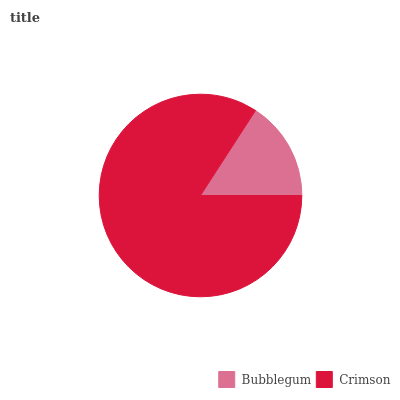Is Bubblegum the minimum?
Answer yes or no. Yes. Is Crimson the maximum?
Answer yes or no. Yes. Is Crimson the minimum?
Answer yes or no. No. Is Crimson greater than Bubblegum?
Answer yes or no. Yes. Is Bubblegum less than Crimson?
Answer yes or no. Yes. Is Bubblegum greater than Crimson?
Answer yes or no. No. Is Crimson less than Bubblegum?
Answer yes or no. No. Is Crimson the high median?
Answer yes or no. Yes. Is Bubblegum the low median?
Answer yes or no. Yes. Is Bubblegum the high median?
Answer yes or no. No. Is Crimson the low median?
Answer yes or no. No. 